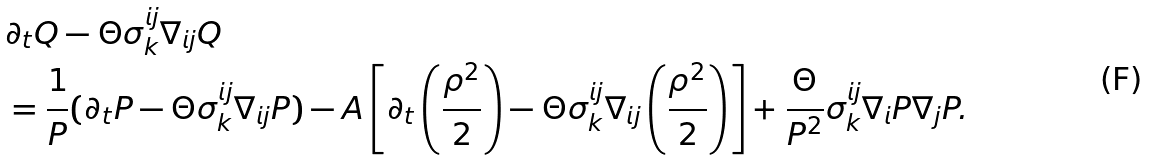Convert formula to latex. <formula><loc_0><loc_0><loc_500><loc_500>& \partial _ { t } Q - \Theta \sigma ^ { i j } _ { k } \nabla _ { i j } Q \\ & = \frac { 1 } { P } ( \partial _ { t } P - \Theta \sigma ^ { i j } _ { k } \nabla _ { i j } P ) - A \left [ \partial _ { t } \left ( \frac { \rho ^ { 2 } } { 2 } \right ) - \Theta \sigma ^ { i j } _ { k } \nabla _ { i j } \left ( \frac { \rho ^ { 2 } } { 2 } \right ) \right ] + \frac { \Theta } { P ^ { 2 } } \sigma ^ { i j } _ { k } \nabla _ { i } P \nabla _ { j } P .</formula> 